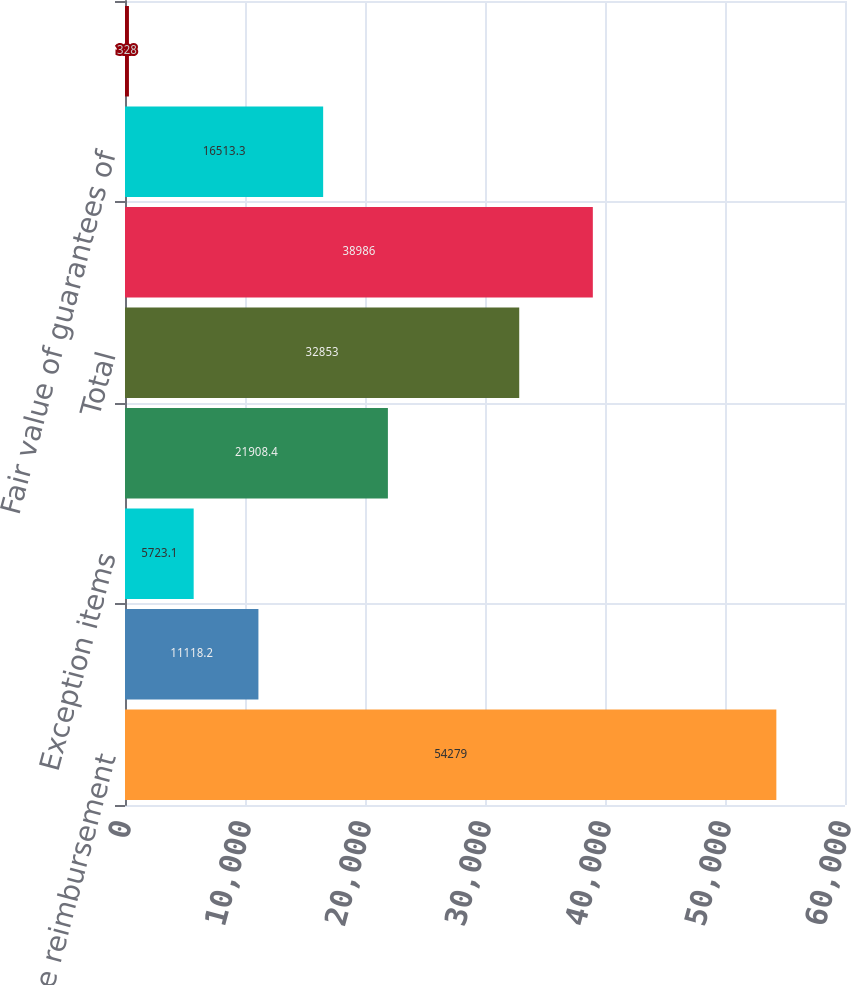<chart> <loc_0><loc_0><loc_500><loc_500><bar_chart><fcel>Interchange reimbursement<fcel>Liability from Members<fcel>Exception items<fcel>Merchant reserves<fcel>Total<fcel>Liability to Members<fcel>Fair value of guarantees of<fcel>Reserves for sales allowances<nl><fcel>54279<fcel>11118.2<fcel>5723.1<fcel>21908.4<fcel>32853<fcel>38986<fcel>16513.3<fcel>328<nl></chart> 